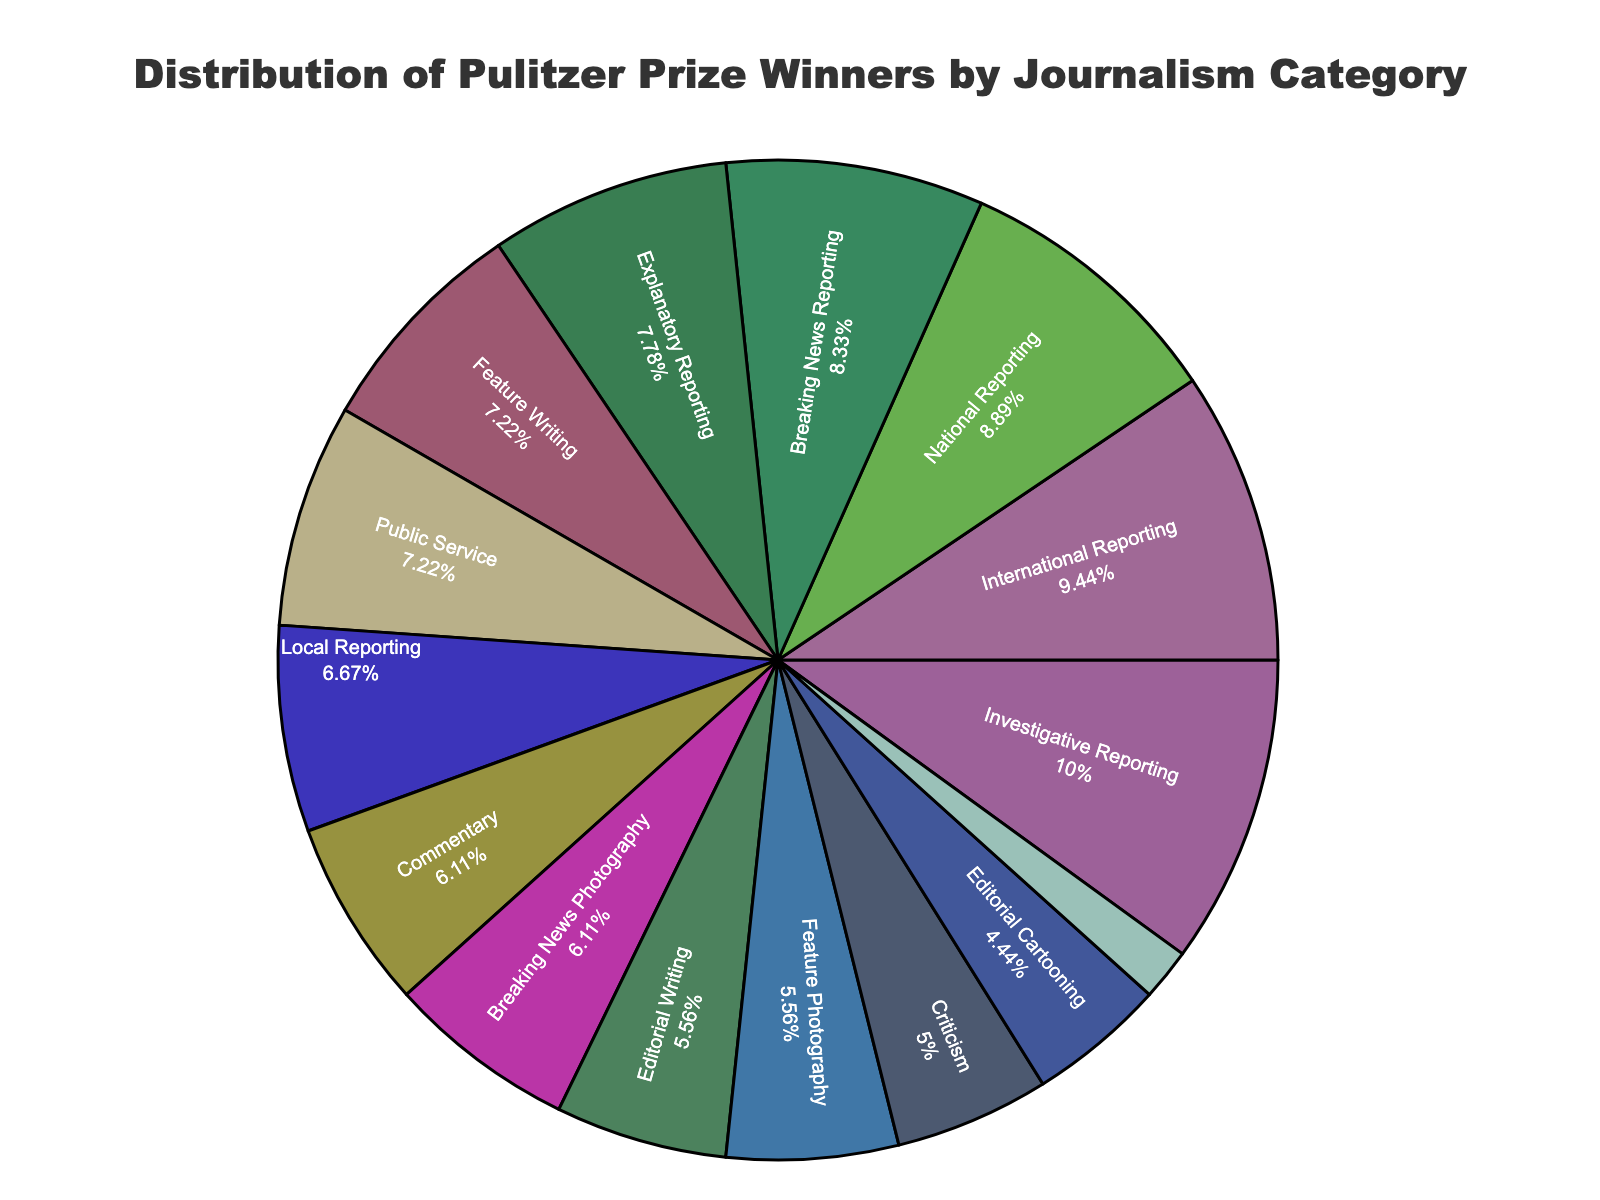What category has the highest percentage of Pulitzer Prize winners? The category with the highest percentage will occupy the largest segment of the pie chart. By observing the chart, the largest segment can be identified.
Answer: Investigative Reporting How many more winners does Breaking News Reporting have compared to Feature Writing? Break down the number of winners in each category: Breaking News Reporting has 15, while Feature Writing has 13. The difference is 15 - 13.
Answer: 2 What is the total percentage of winners in Commentary, Criticism, and Editorial Writing combined? Calculate the percentage summing the individual percentages for Commentary, Criticism, and Editorial Writing. Adding them together will yield: 7.14% (Commentary) + 5.84% (Criticism) + 6.49% (Editorial Writing).
Answer: 19.47% Which category has the smallest percentage of Pulitzer Prize winners? The category with the smallest percentage will occupy the smallest segment of the pie chart. By observing the chart, the smallest segment can be identified.
Answer: Audio Reporting How does the number of winners in International Reporting compare to National Reporting? Check the number of winners in each category: International Reporting has 17, whereas National Reporting has 16. Therefore, International Reporting has more winners.
Answer: International Reporting has more What is the combined percentage of the three categories with the highest number of winners? Identify the top three categories with the highest number of winners: Investigative Reporting (18), International Reporting (17), and National Reporting (16). Sum their percentages: 20.93% (Investigative Reporting) + 19.77% (International Reporting) + 18.60% (National Reporting).
Answer: 59.3% Which category has a higher percentage of winners, Local Reporting or Feature Photography? Look at the percentage of winners for each category: Local Reporting and Feature Photography, then compare them.
Answer: Local Reporting What is the median percentage of Pulitzer Prize winners across all categories? Arrange the percentages in ascending order and find the middle value. If the number of categories is odd, the median is the middle value, if even, it's the average of the two middle values. Calculate percentages first (6.49%, 5.84%, 3.90%, …), find the middle percentage of 14 categories.
Answer: 7.79% What are the three categories with percentages closest to 10%? Look at the chart and identify the categories with percentages near 10%. Determine the exact values and list the three closest.
Answer: Commentary, Editorial Writing, Breaking News Photography 